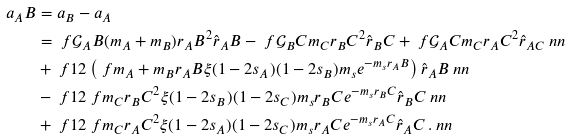Convert formula to latex. <formula><loc_0><loc_0><loc_500><loc_500>a _ { A } B & = a _ { B } - a _ { A } \\ & = \ f { \mathcal { G } _ { A } B ( m _ { A } + m _ { B } ) } { r _ { A } B ^ { 2 } } \hat { r } _ { A } B - \ f { \mathcal { G } _ { B } C m _ { C } } { r _ { B } C ^ { 2 } } \hat { r } _ { B } C + \ f { \mathcal { G } _ { A } C m _ { C } } { r _ { A } C ^ { 2 } } \hat { r } _ { A C } \ n n \\ & + \ f { 1 } { 2 } \left ( \ f { m _ { A } + m _ { B } } { r _ { A } B } \xi ( 1 - 2 s _ { A } ) ( 1 - 2 s _ { B } ) m _ { s } e ^ { - m _ { s } r _ { A } B } \right ) \hat { r } _ { A } B \ n n \\ & - \ f { 1 } { 2 } \ f { m _ { C } } { r _ { B } C ^ { 2 } } \xi ( 1 - 2 s _ { B } ) ( 1 - 2 s _ { C } ) m _ { s } r _ { B } C e ^ { - m _ { s } r _ { B } C } \hat { r } _ { B } C \ n n \\ & + \ f { 1 } { 2 } \ f { m _ { C } } { r _ { A } C ^ { 2 } } \xi ( 1 - 2 s _ { A } ) ( 1 - 2 s _ { C } ) m _ { s } r _ { A } C e ^ { - m _ { s } r _ { A } C } \hat { r } _ { A } C \, . \ n n</formula> 